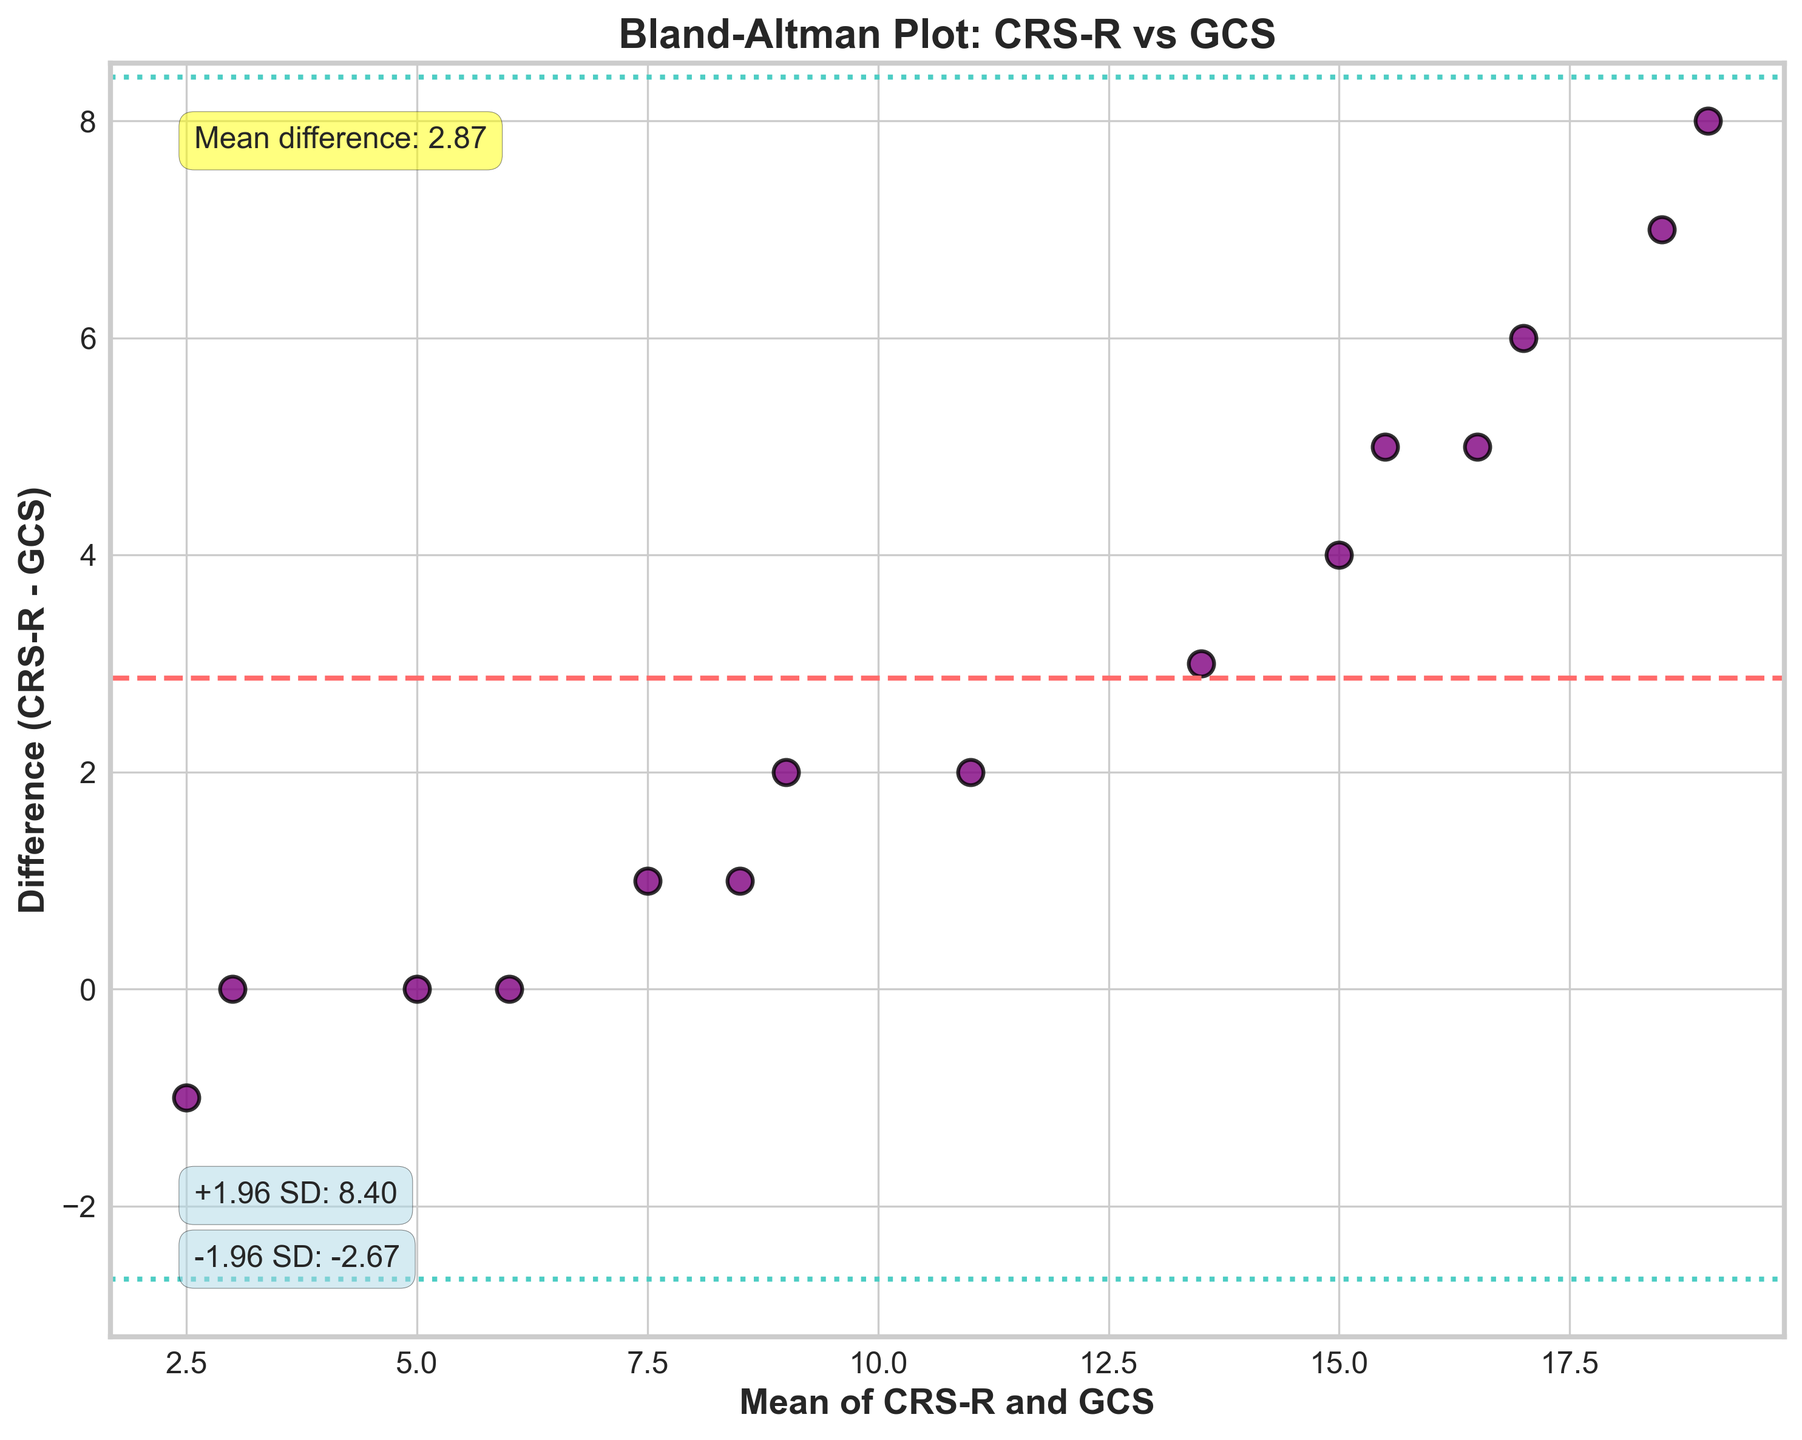What is the title of the plot? Look at the top center of the figure to find the title. The title of the plot is explicitly written there.
Answer: Bland-Altman Plot: CRS-R vs GCS How many data points are represented on the plot? Count the number of scatter points plotted on the Bland-Altman Plot, which correspond to the patients' data considered.
Answer: 15 What is the color of the mean difference line? Observe the color of the horizontal line that represents the mean difference. It is clearly distinguishable amongst other lines.
Answer: Red What does the dashed line represent in the figure? Note the dashed horizontal line in the plot, along with its color. Check the annotations or legend which usually denotes what different lines represent.
Answer: Mean difference What is the value of the mean difference between CRS-R and GCS? Refer to the annotation within the plot that mentions "Mean difference". The value is explicitly provided.
Answer: 3.93 What do the dotted lines represent in the figure? Observe the horizontal dotted lines and their corresponding annotations. These annotations usually explain what the lines signify in terms of statistical measures.
Answer: Limits of Agreement (+1.96 SD and -1.96 SD) What are the values of the upper and lower limits of agreement? Check the annotations next to the dotted lines on the plot to find the respective numerical values of the limits of agreement.
Answer: Upper: 8.36, Lower: -0.50 Which patient has the highest mean score of CRS-R and GCS combined? Calculate the mean scores by averaging the CRS-R and GCS values for each patient, then identify the highest mean score.
Answer: Patient 10 Is there any clear trend or correlation you observe from the scatter points on the plot? Examine the pattern of scatter points overall to determine if there is any consistent trend or obvious correlation between the values.
Answer: No clear trend Which patients have zero difference between CRS-R and GCS scores? Look for points that lie on the horizontal line at y=0, which indicates zero difference. Count and identify these patients.
Answer: Patient 4 and Patient 7 